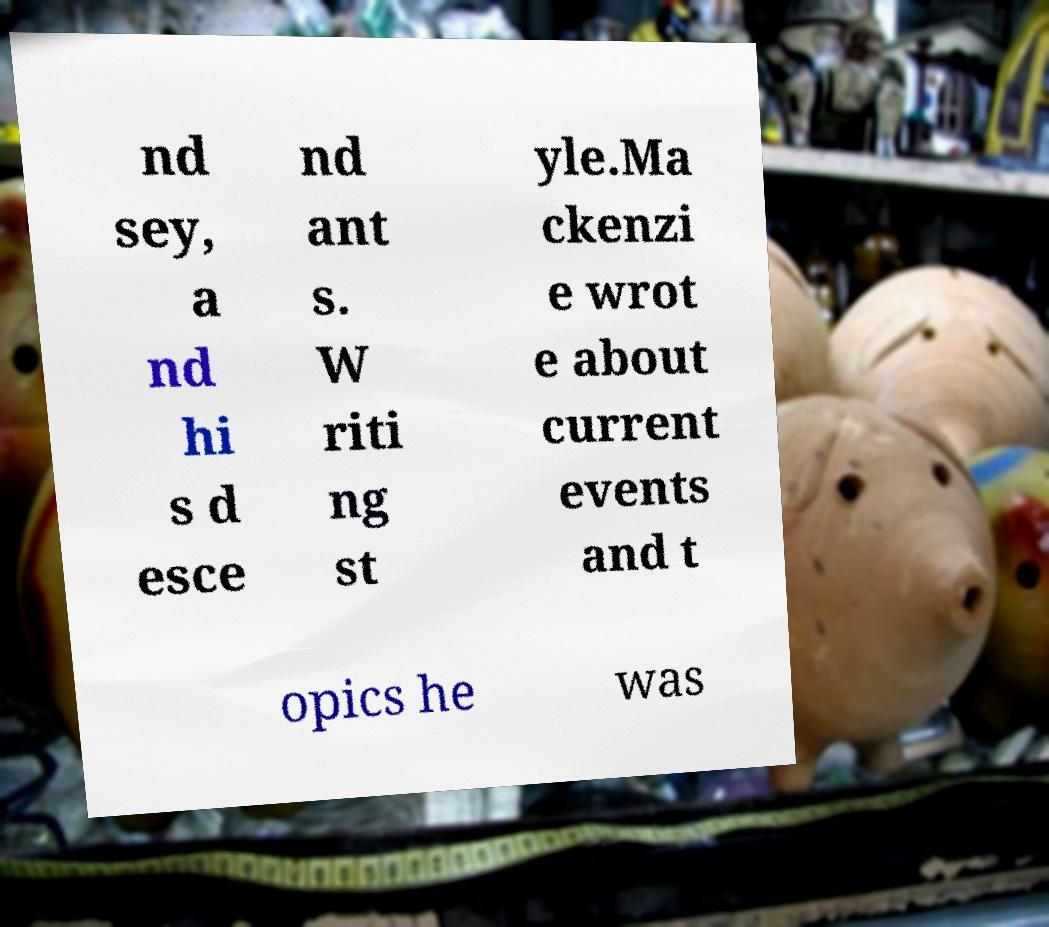Could you extract and type out the text from this image? nd sey, a nd hi s d esce nd ant s. W riti ng st yle.Ma ckenzi e wrot e about current events and t opics he was 